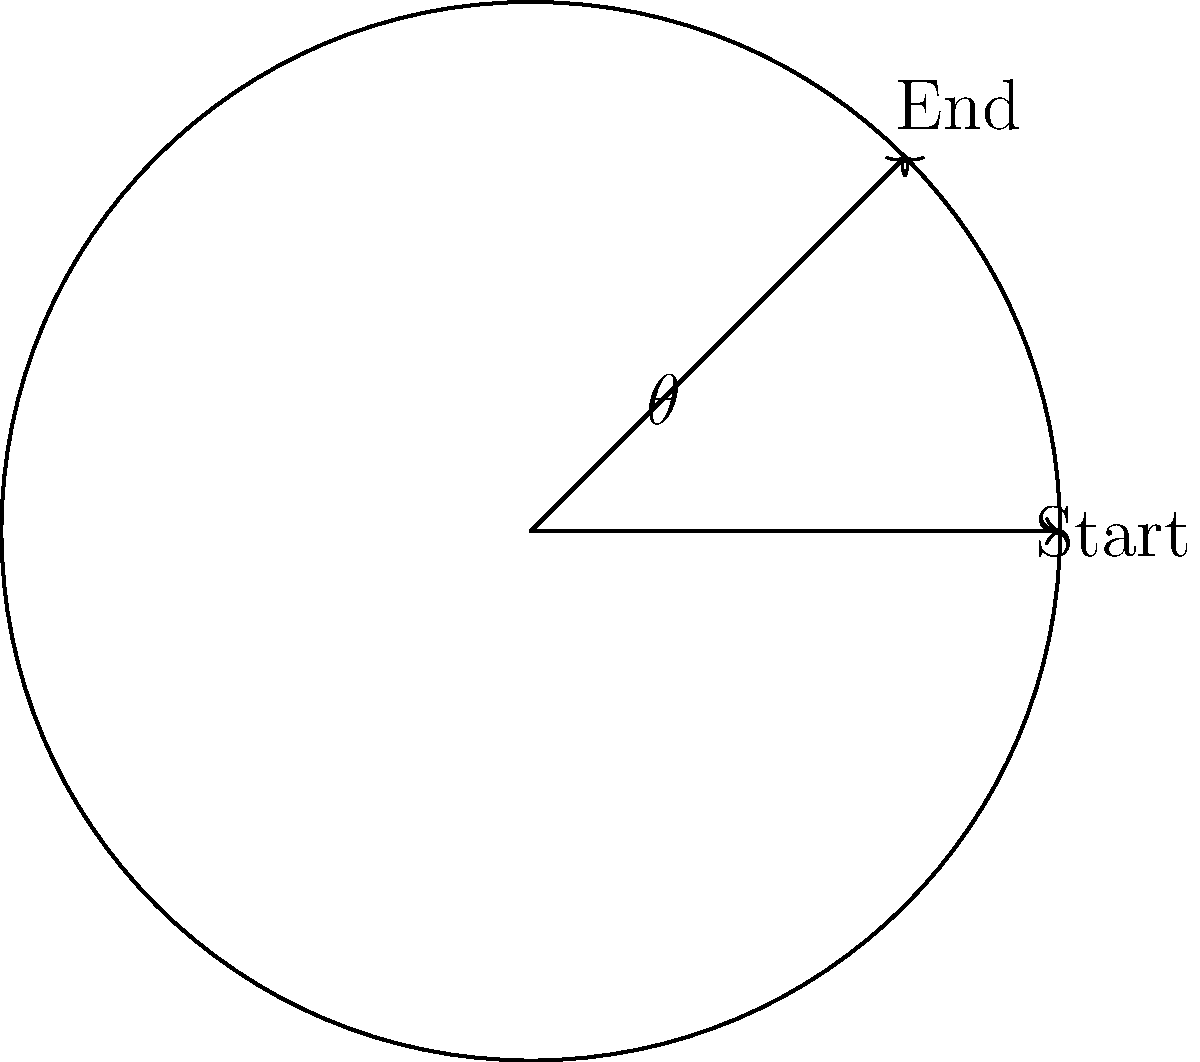A vinyl record on a turntable rotates from its starting position to the end of a musical phrase. If the radius of the record is 6 inches and the stylus has moved 4.71 inches along the circumference, what is the angle of rotation $\theta$ in degrees? To solve this problem, we'll use the relationship between arc length, radius, and angle in radians. Then we'll convert the result to degrees.

Step 1: Recall the formula for arc length:
$s = r\theta$, where $s$ is arc length, $r$ is radius, and $\theta$ is angle in radians.

Step 2: Rearrange the formula to solve for $\theta$:
$\theta = \frac{s}{r}$

Step 3: Substitute the known values:
$\theta = \frac{4.71\text{ inches}}{6\text{ inches}} = 0.785\text{ radians}$

Step 4: Convert radians to degrees:
$\theta_{\text{degrees}} = \theta_{\text{radians}} \times \frac{180°}{\pi}$
$\theta_{\text{degrees}} = 0.785 \times \frac{180°}{\pi} \approx 45°$

Therefore, the angle of rotation is approximately 45 degrees.
Answer: $45°$ 